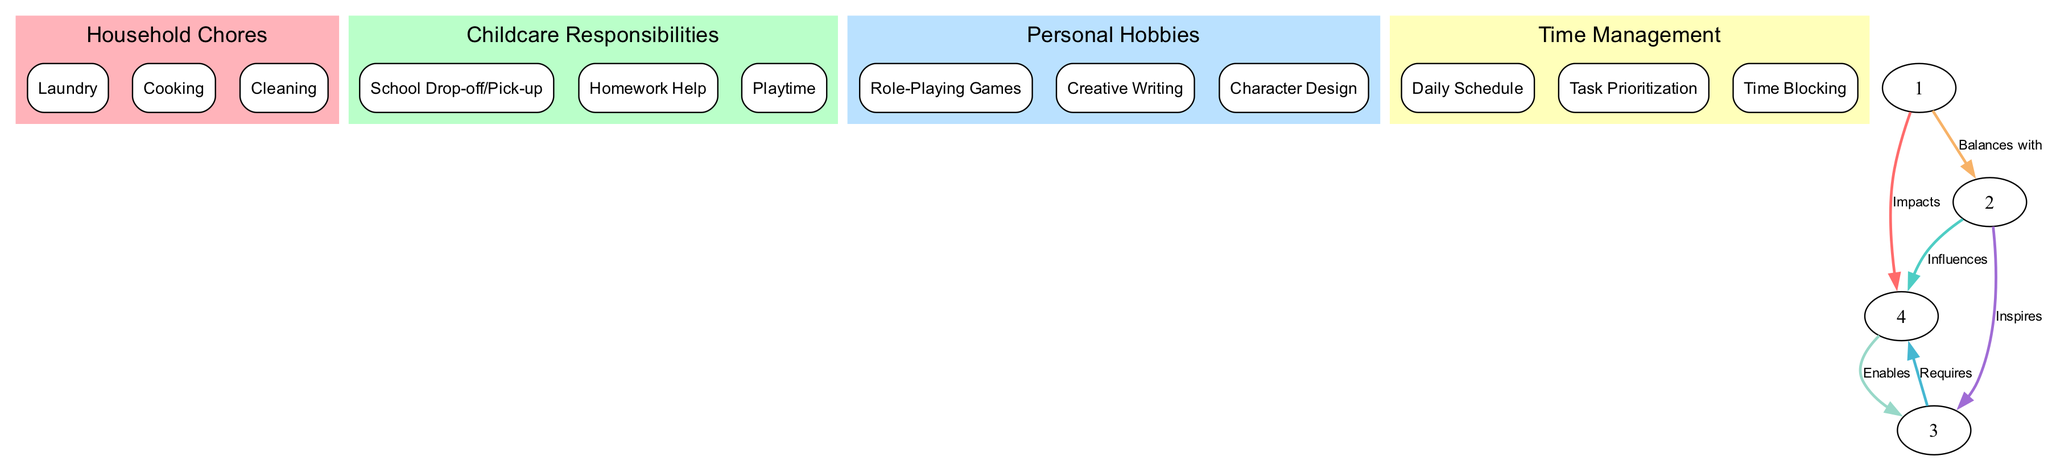What are the three main categories depicted in the diagram? The diagram shows three main categories: Household Chores, Childcare Responsibilities, and Personal Hobbies. Each category contains sub-nodes that break down specific tasks or activities.
Answer: Household Chores, Childcare Responsibilities, Personal Hobbies How many subcategories does "Household Chores" have? The "Household Chores" node includes three subcategories: Laundry, Cooking, and Cleaning. Therefore, the total count of subcategories is three.
Answer: 3 What is the relationship between "Childcare Responsibilities" and "Time Management"? The diagram indicates that "Childcare Responsibilities" Influences "Time Management." The edge labeled as "Influences" shows this directional relationship.
Answer: Influences Which node requires the most from "Time Management"? The edge labeled "Requires" shows that "Personal Hobbies" is the node that requires the most from "Time Management," as it directly connects to it with this label.
Answer: Personal Hobbies What does "Cleaning" balance with? The edge labeled "Balances with" indicates that "Cleaning" balances with "Childcare Responsibilities," suggesting an interrelation where both categories must be managed to maintain balance.
Answer: Childcare Responsibilities How many edges connect "Household Chores" to "Childcare Responsibilities"? The diagram indicates that there is one edge connecting "Household Chores" to "Childcare Responsibilities" with the label "Balances with." Thus, the total count of edges is one.
Answer: 1 Which subcategory of "Personal Hobbies" is directly connected to "Time Management"? The edge labeled "Enables" signifies that "Time Management" enables the subcategory "Role-Playing Games," establishing a direct connection between them.
Answer: Role-Playing Games How does "Childcare Responsibilities" inspire "Personal Hobbies"? The connection labeled "Inspires" shows that "Childcare Responsibilities" has a motivational influence on "Personal Hobbies," suggesting that these duties can lead to creative outlets.
Answer: Inspires 